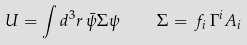Convert formula to latex. <formula><loc_0><loc_0><loc_500><loc_500>U = \int d ^ { 3 } r \, \bar { \psi } \/ \Sigma \psi \, \quad \Sigma = \, f _ { i } \, \Gamma ^ { i } A _ { i }</formula> 